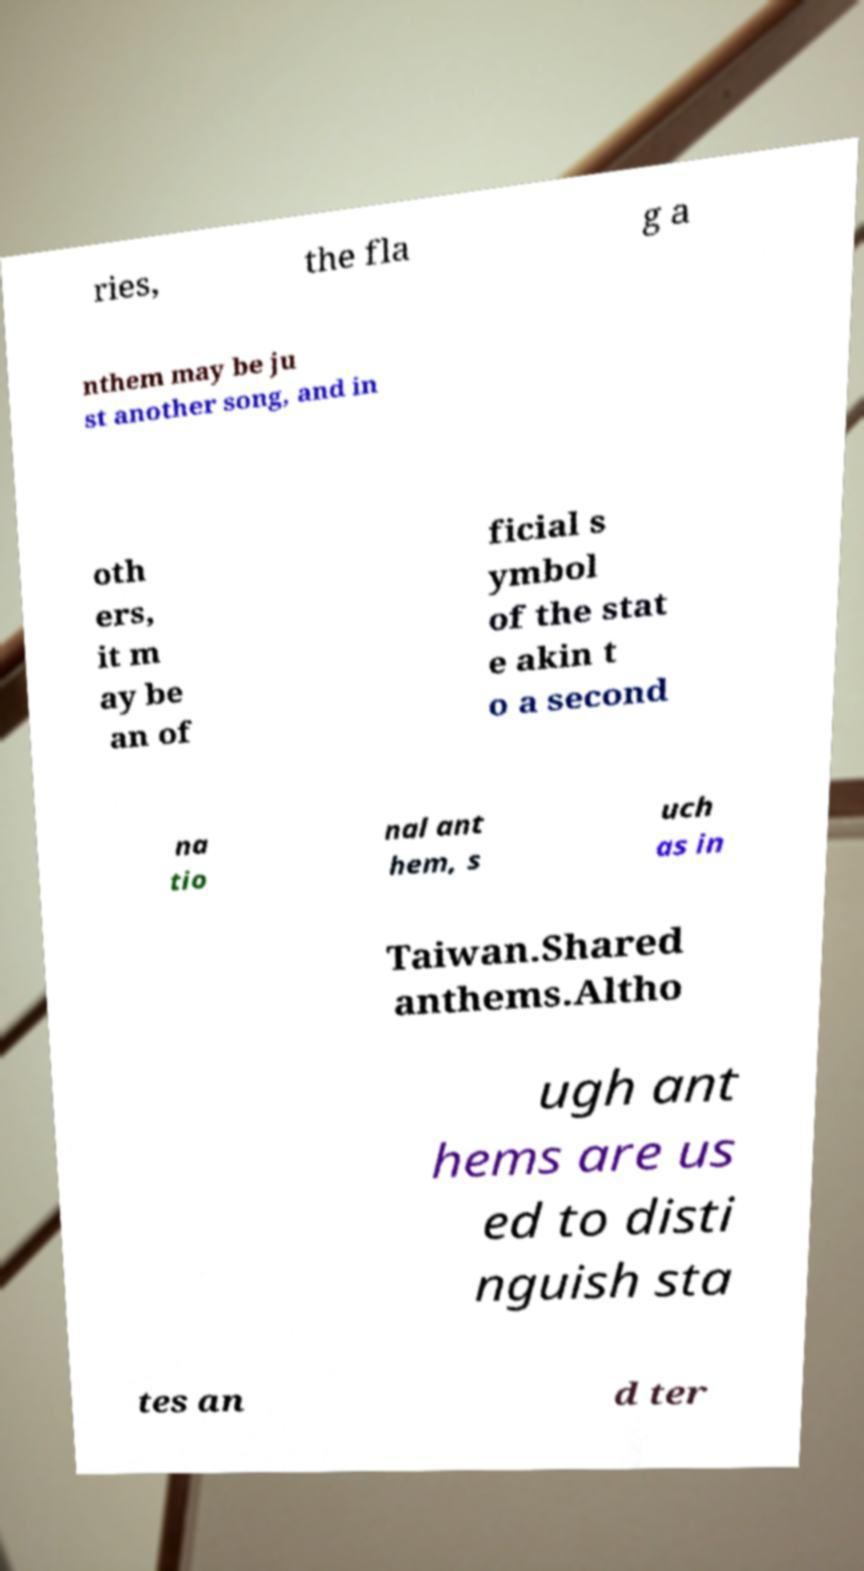There's text embedded in this image that I need extracted. Can you transcribe it verbatim? ries, the fla g a nthem may be ju st another song, and in oth ers, it m ay be an of ficial s ymbol of the stat e akin t o a second na tio nal ant hem, s uch as in Taiwan.Shared anthems.Altho ugh ant hems are us ed to disti nguish sta tes an d ter 